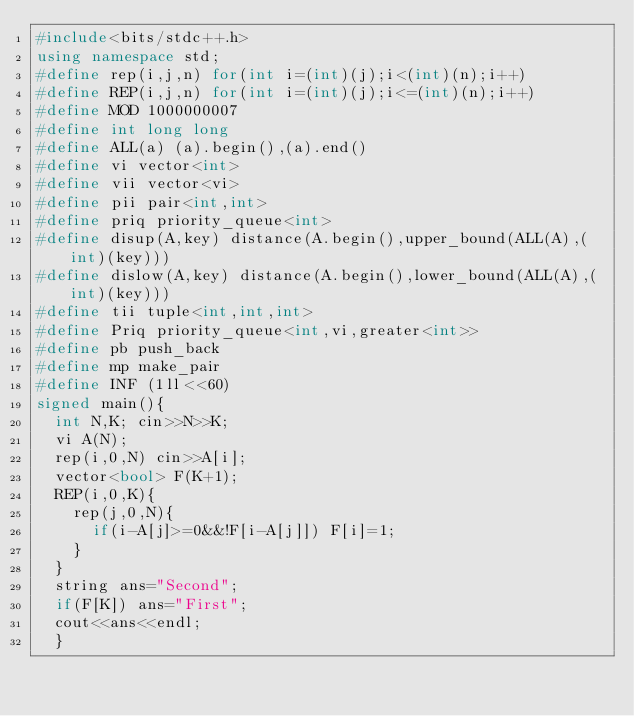Convert code to text. <code><loc_0><loc_0><loc_500><loc_500><_C++_>#include<bits/stdc++.h>
using namespace std;
#define rep(i,j,n) for(int i=(int)(j);i<(int)(n);i++)
#define REP(i,j,n) for(int i=(int)(j);i<=(int)(n);i++)
#define MOD 1000000007
#define int long long
#define ALL(a) (a).begin(),(a).end()
#define vi vector<int>
#define vii vector<vi>
#define pii pair<int,int>
#define priq priority_queue<int>
#define disup(A,key) distance(A.begin(),upper_bound(ALL(A),(int)(key)))
#define dislow(A,key) distance(A.begin(),lower_bound(ALL(A),(int)(key)))
#define tii tuple<int,int,int>
#define Priq priority_queue<int,vi,greater<int>>
#define pb push_back
#define mp make_pair
#define INF (1ll<<60)
signed main(){
  int N,K; cin>>N>>K;
  vi A(N);
  rep(i,0,N) cin>>A[i];
  vector<bool> F(K+1);
  REP(i,0,K){
    rep(j,0,N){
      if(i-A[j]>=0&&!F[i-A[j]]) F[i]=1;
    }
  }
  string ans="Second";
  if(F[K]) ans="First";
  cout<<ans<<endl;
  }
</code> 